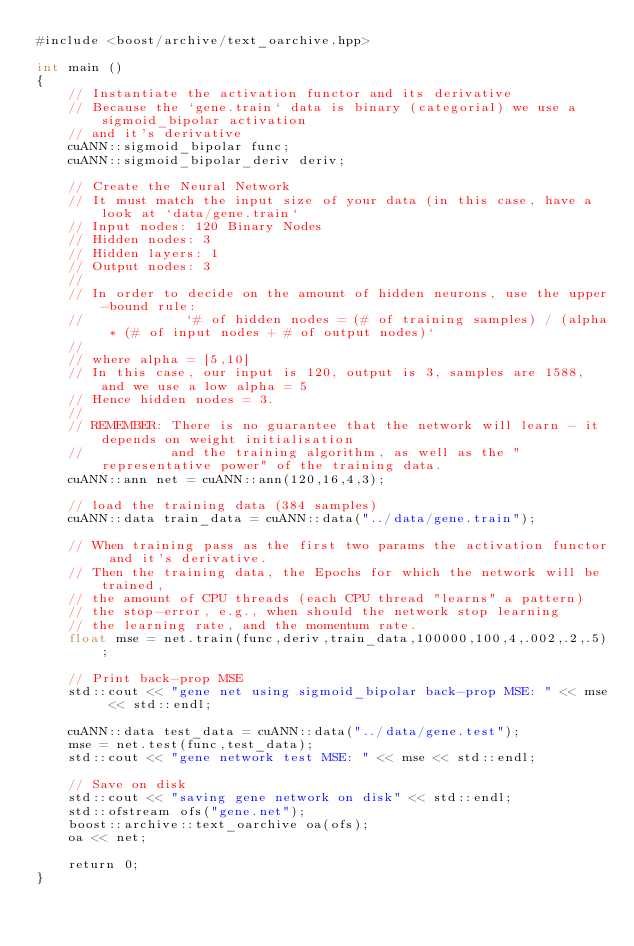Convert code to text. <code><loc_0><loc_0><loc_500><loc_500><_Cuda_>#include <boost/archive/text_oarchive.hpp>

int main ()
{
    // Instantiate the activation functor and its derivative
    // Because the `gene.train` data is binary (categorial) we use a sigmoid_bipolar activation
    // and it's derivative
    cuANN::sigmoid_bipolar func;
    cuANN::sigmoid_bipolar_deriv deriv;

    // Create the Neural Network
    // It must match the input size of your data (in this case, have a look at `data/gene.train`
    // Input nodes: 120 Binary Nodes 
    // Hidden nodes: 3
    // Hidden layers: 1
    // Output nodes: 3
    //
    // In order to decide on the amount of hidden neurons, use the upper-bound rule:
    //             `# of hidden nodes = (# of training samples) / (alpha * (# of input nodes + # of output nodes)`
    //
    // where alpha = [5,10]
    // In this case, our input is 120, output is 3, samples are 1588, and we use a low alpha = 5
    // Hence hidden nodes = 3.
    //
    // REMEMBER: There is no guarantee that the network will learn - it depends on weight initialisation
    //           and the training algorithm, as well as the "representative power" of the training data.
    cuANN::ann net = cuANN::ann(120,16,4,3);

    // load the training data (384 samples)
    cuANN::data train_data = cuANN::data("../data/gene.train");

    // When training pass as the first two params the activation functor and it's derivative.
    // Then the training data, the Epochs for which the network will be trained,
    // the amount of CPU threads (each CPU thread "learns" a pattern)
    // the stop-error, e.g., when should the network stop learning
    // the learning rate, and the momentum rate.
    float mse = net.train(func,deriv,train_data,100000,100,4,.002,.2,.5);

    // Print back-prop MSE
    std::cout << "gene net using sigmoid_bipolar back-prop MSE: " << mse << std::endl;

    cuANN::data test_data = cuANN::data("../data/gene.test");
    mse = net.test(func,test_data);
    std::cout << "gene network test MSE: " << mse << std::endl;
   
    // Save on disk
    std::cout << "saving gene network on disk" << std::endl;
    std::ofstream ofs("gene.net");
    boost::archive::text_oarchive oa(ofs);
    oa << net;
    
    return 0;
}
</code> 